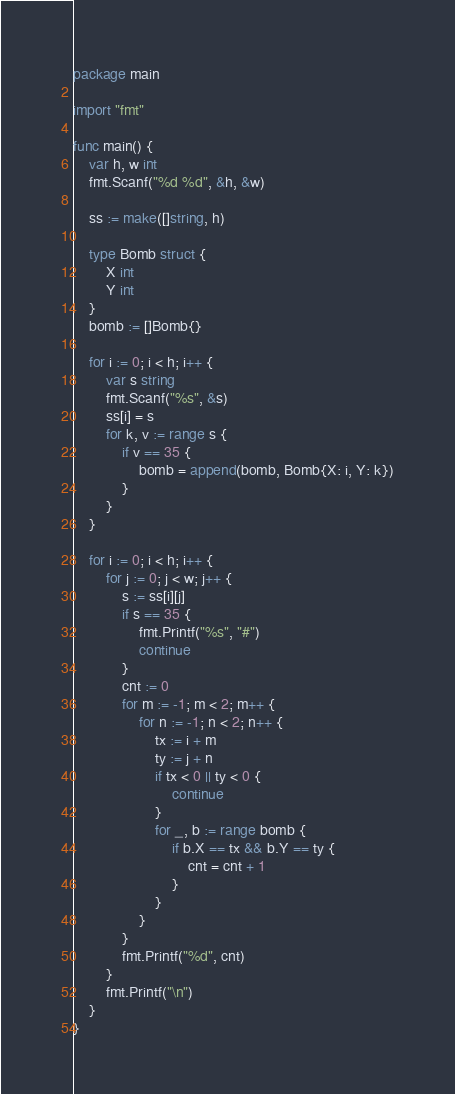Convert code to text. <code><loc_0><loc_0><loc_500><loc_500><_Go_>package main

import "fmt"

func main() {
	var h, w int
	fmt.Scanf("%d %d", &h, &w)

	ss := make([]string, h)

	type Bomb struct {
		X int
		Y int
	}
	bomb := []Bomb{}

	for i := 0; i < h; i++ {
		var s string
		fmt.Scanf("%s", &s)
		ss[i] = s
		for k, v := range s {
			if v == 35 {
				bomb = append(bomb, Bomb{X: i, Y: k})
			}
		}
	}

	for i := 0; i < h; i++ {
		for j := 0; j < w; j++ {
			s := ss[i][j]
			if s == 35 {
				fmt.Printf("%s", "#")
				continue
			}
			cnt := 0
			for m := -1; m < 2; m++ {
				for n := -1; n < 2; n++ {
					tx := i + m
					ty := j + n
					if tx < 0 || ty < 0 {
						continue
					}
					for _, b := range bomb {
						if b.X == tx && b.Y == ty {
							cnt = cnt + 1
						}
					}
				}
			}
			fmt.Printf("%d", cnt)
		}
		fmt.Printf("\n")
	}
}</code> 